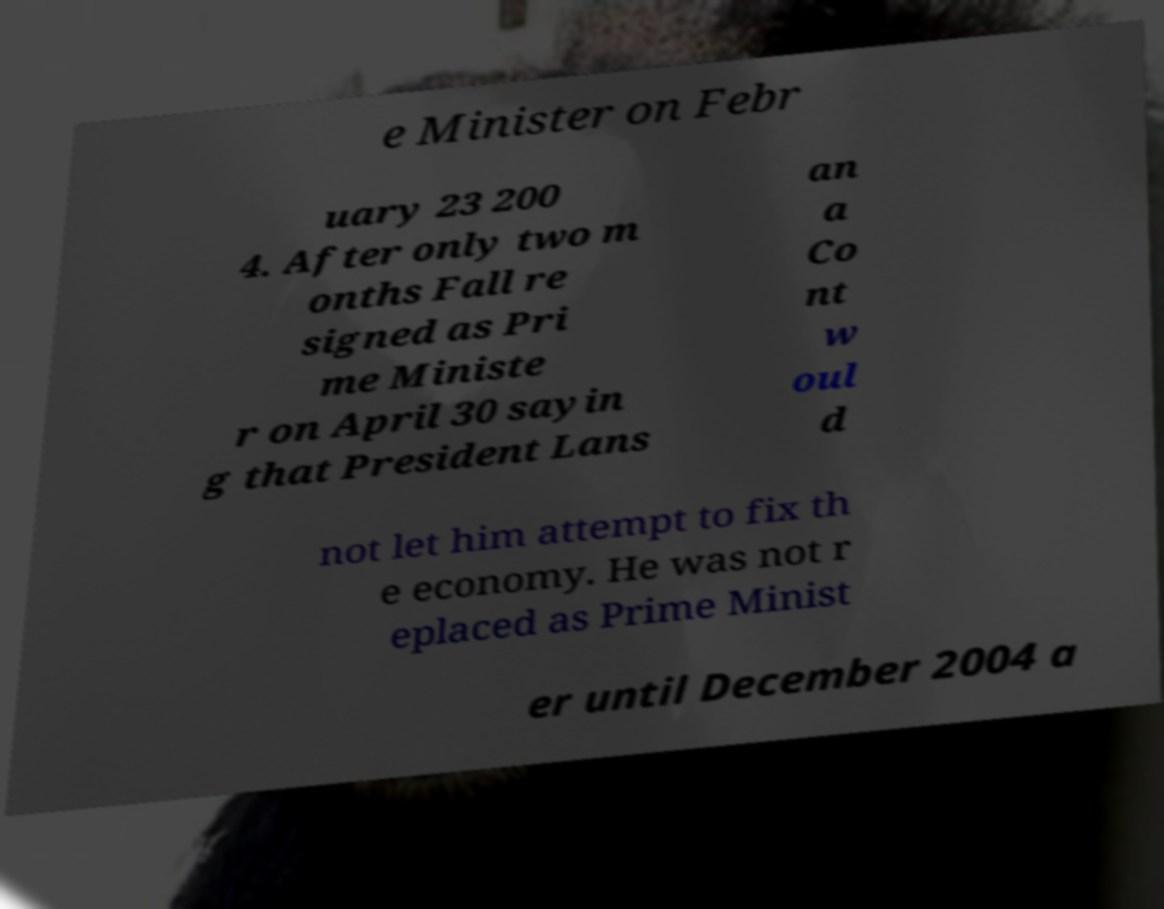Can you read and provide the text displayed in the image?This photo seems to have some interesting text. Can you extract and type it out for me? e Minister on Febr uary 23 200 4. After only two m onths Fall re signed as Pri me Ministe r on April 30 sayin g that President Lans an a Co nt w oul d not let him attempt to fix th e economy. He was not r eplaced as Prime Minist er until December 2004 a 